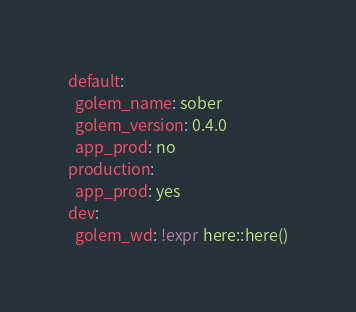Convert code to text. <code><loc_0><loc_0><loc_500><loc_500><_YAML_>default:
  golem_name: sober
  golem_version: 0.4.0
  app_prod: no
production:
  app_prod: yes
dev:
  golem_wd: !expr here::here()
</code> 